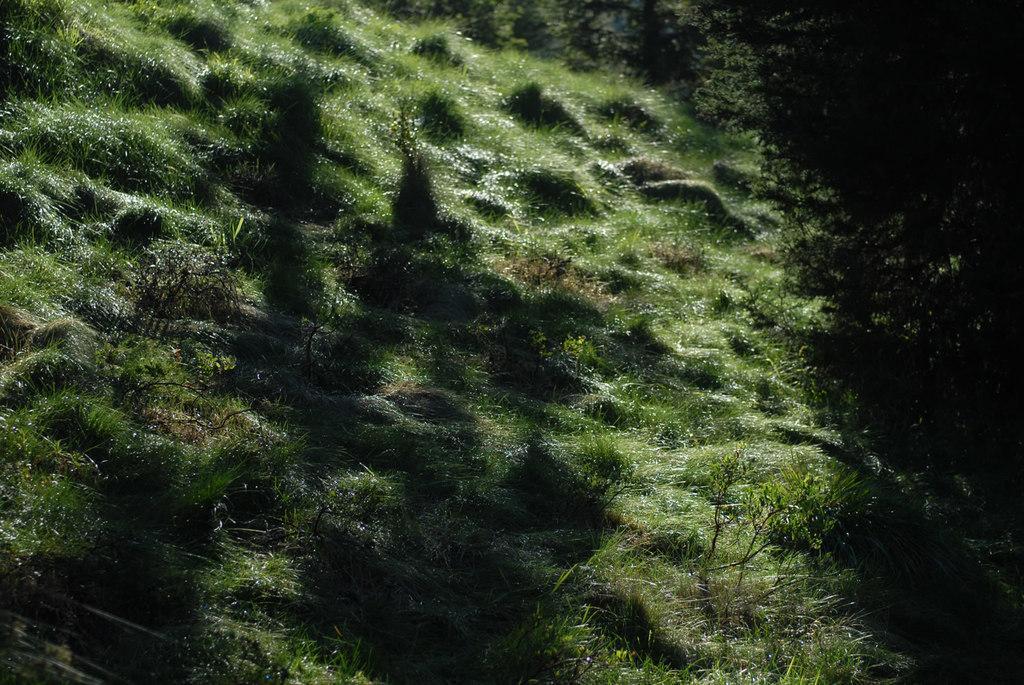How would you summarize this image in a sentence or two? In this image we can see grass and plants. 